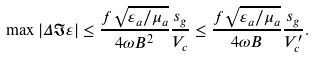<formula> <loc_0><loc_0><loc_500><loc_500>\max | \Delta \Im \varepsilon | \leq \frac { f \sqrt { \varepsilon _ { a } / \mu _ { a } } } { 4 \omega B ^ { 2 } } \frac { s _ { g } } { V _ { c } } \leq \frac { f \sqrt { \varepsilon _ { a } / \mu _ { a } } } { 4 \omega B } \frac { s _ { g } } { V _ { c } ^ { \prime } } .</formula> 